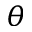<formula> <loc_0><loc_0><loc_500><loc_500>\theta</formula> 